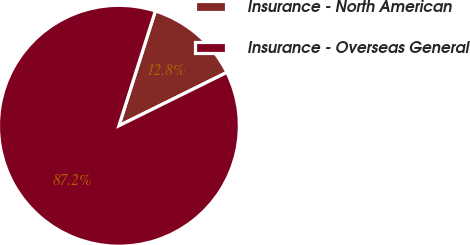<chart> <loc_0><loc_0><loc_500><loc_500><pie_chart><fcel>Insurance - North American<fcel>Insurance - Overseas General<nl><fcel>12.8%<fcel>87.2%<nl></chart> 